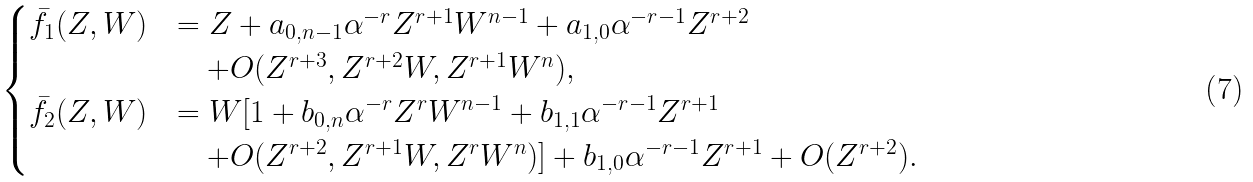Convert formula to latex. <formula><loc_0><loc_0><loc_500><loc_500>\begin{cases} \bar { f } _ { 1 } ( Z , W ) & = Z + a _ { 0 , n - 1 } \alpha ^ { - r } Z ^ { r + 1 } W ^ { n - 1 } + a _ { 1 , 0 } \alpha ^ { - r - 1 } Z ^ { r + 2 } \\ & \quad + O ( Z ^ { r + 3 } , Z ^ { r + 2 } W , Z ^ { r + 1 } W ^ { n } ) , \\ \bar { f } _ { 2 } ( Z , W ) & = W [ 1 + b _ { 0 , n } \alpha ^ { - r } Z ^ { r } W ^ { n - 1 } + b _ { 1 , 1 } \alpha ^ { - r - 1 } Z ^ { r + 1 } \\ & \quad + O ( Z ^ { r + 2 } , Z ^ { r + 1 } W , Z ^ { r } W ^ { n } ) ] + b _ { 1 , 0 } \alpha ^ { - r - 1 } Z ^ { r + 1 } + O ( Z ^ { r + 2 } ) . \end{cases}</formula> 